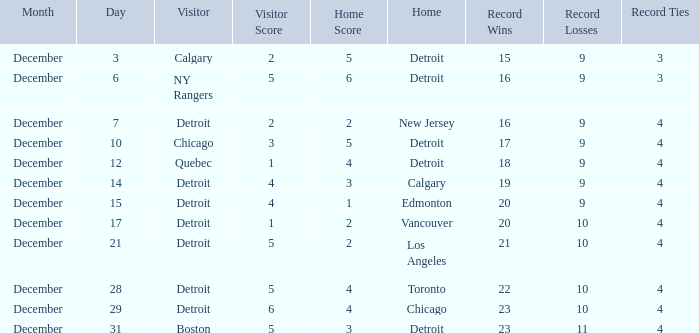Who is the visitor on the date december 31? Boston. Can you parse all the data within this table? {'header': ['Month', 'Day', 'Visitor', 'Visitor Score', 'Home Score', 'Home', 'Record Wins', 'Record Losses', 'Record Ties'], 'rows': [['December', '3', 'Calgary', '2', '5', 'Detroit', '15', '9', '3'], ['December', '6', 'NY Rangers', '5', '6', 'Detroit', '16', '9', '3'], ['December', '7', 'Detroit', '2', '2', 'New Jersey', '16', '9', '4'], ['December', '10', 'Chicago', '3', '5', 'Detroit', '17', '9', '4'], ['December', '12', 'Quebec', '1', '4', 'Detroit', '18', '9', '4'], ['December', '14', 'Detroit', '4', '3', 'Calgary', '19', '9', '4'], ['December', '15', 'Detroit', '4', '1', 'Edmonton', '20', '9', '4'], ['December', '17', 'Detroit', '1', '2', 'Vancouver', '20', '10', '4'], ['December', '21', 'Detroit', '5', '2', 'Los Angeles', '21', '10', '4'], ['December', '28', 'Detroit', '5', '4', 'Toronto', '22', '10', '4'], ['December', '29', 'Detroit', '6', '4', 'Chicago', '23', '10', '4'], ['December', '31', 'Boston', '5', '3', 'Detroit', '23', '11', '4']]} 